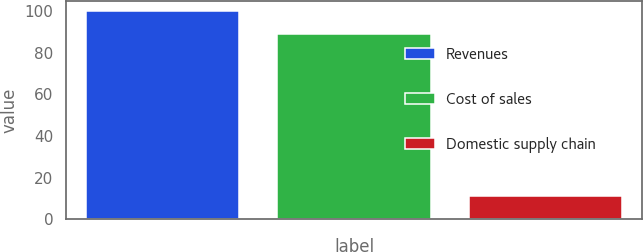Convert chart. <chart><loc_0><loc_0><loc_500><loc_500><bar_chart><fcel>Revenues<fcel>Cost of sales<fcel>Domestic supply chain<nl><fcel>100<fcel>88.9<fcel>11.1<nl></chart> 